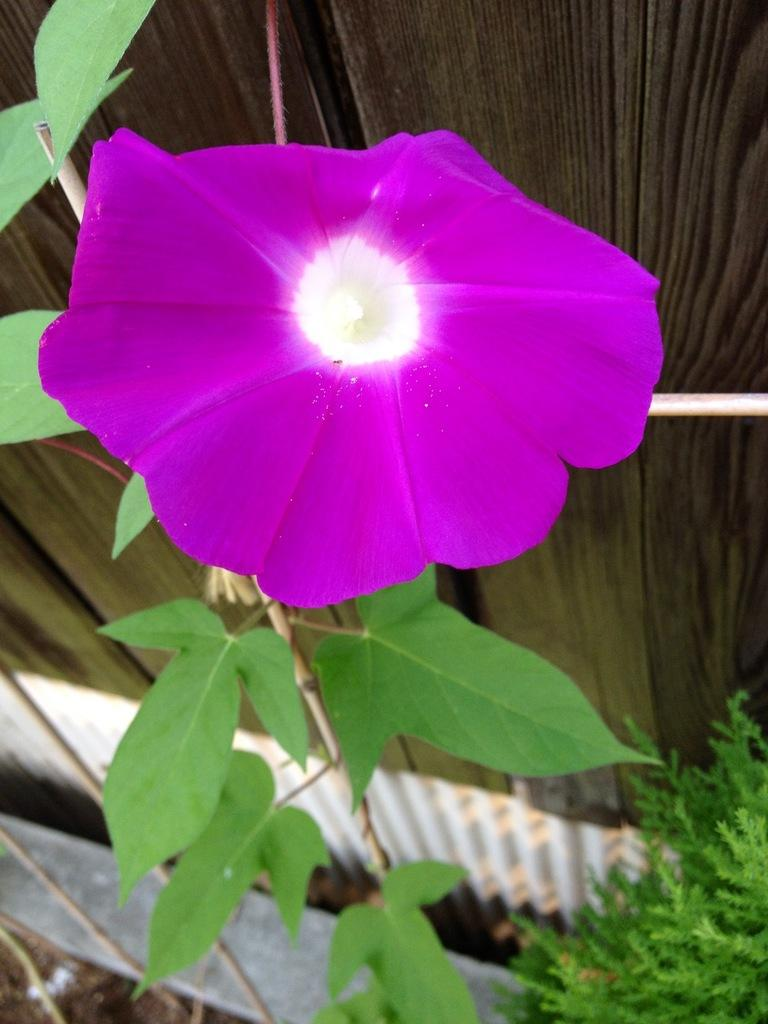What is the main subject of the image? There is a flower in the center of the image. What color is the flower? The flower is purple. What other elements are present at the bottom of the image? There are plants and leaves at the bottom of the image. What can be seen in the background of the image? There is a fence in the background of the image. What type of skate is the cat using to perform tricks on the edge of the fence in the image? There is no cat or skate present in the image, so it is not possible to determine the type of skate being used. 